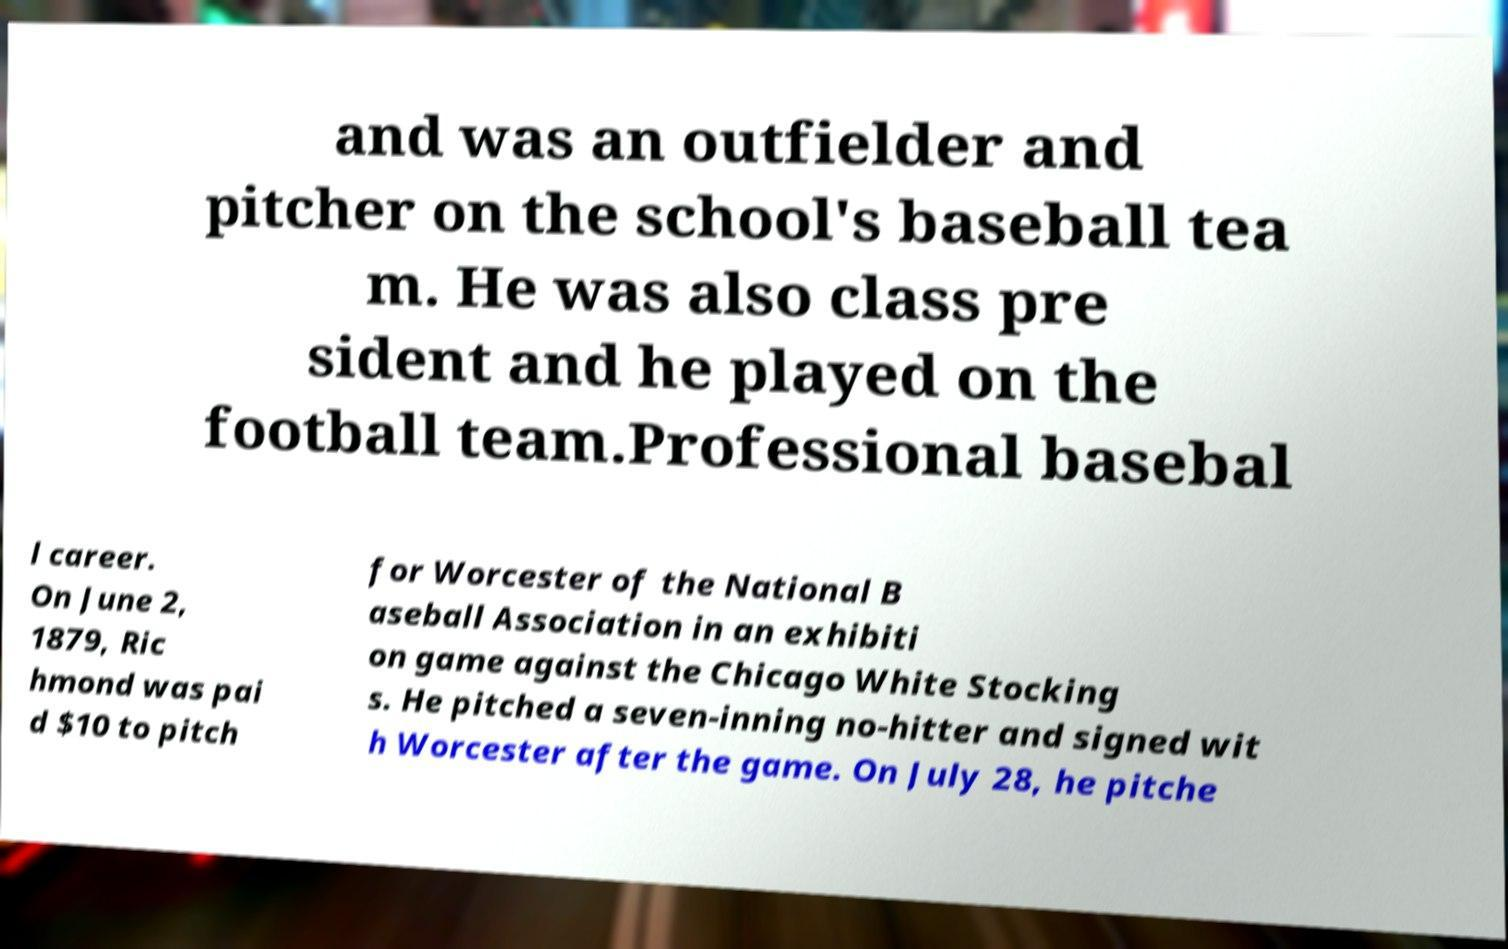Could you extract and type out the text from this image? and was an outfielder and pitcher on the school's baseball tea m. He was also class pre sident and he played on the football team.Professional basebal l career. On June 2, 1879, Ric hmond was pai d $10 to pitch for Worcester of the National B aseball Association in an exhibiti on game against the Chicago White Stocking s. He pitched a seven-inning no-hitter and signed wit h Worcester after the game. On July 28, he pitche 